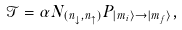Convert formula to latex. <formula><loc_0><loc_0><loc_500><loc_500>\mathcal { T } = \alpha N _ { ( n _ { \downarrow } , n _ { \uparrow } ) } P _ { | m _ { i } \rangle \rightarrow | m _ { f } \rangle } ,</formula> 